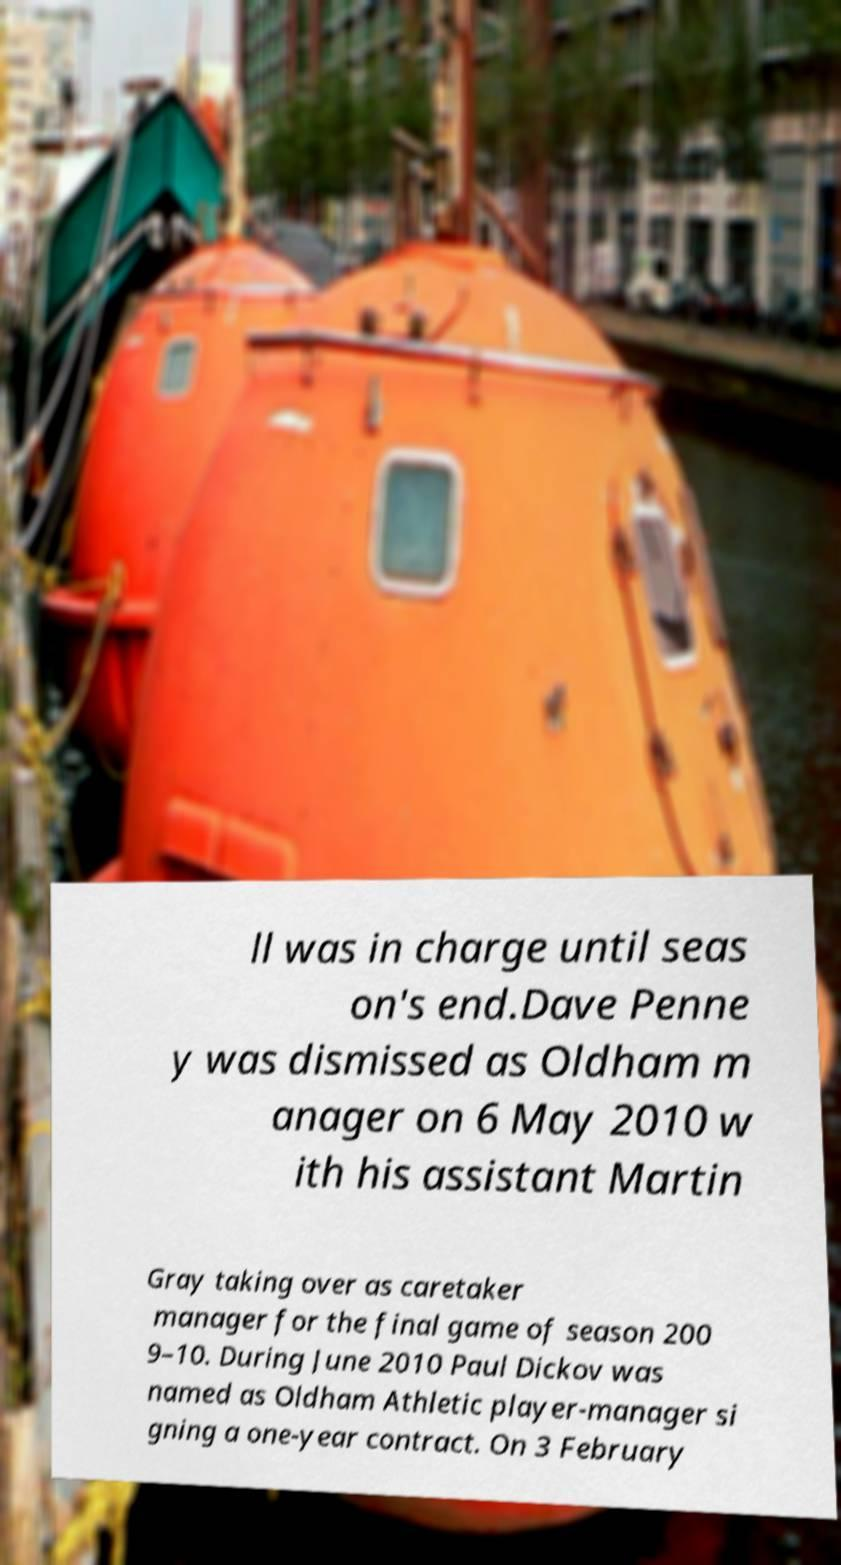There's text embedded in this image that I need extracted. Can you transcribe it verbatim? ll was in charge until seas on's end.Dave Penne y was dismissed as Oldham m anager on 6 May 2010 w ith his assistant Martin Gray taking over as caretaker manager for the final game of season 200 9–10. During June 2010 Paul Dickov was named as Oldham Athletic player-manager si gning a one-year contract. On 3 February 